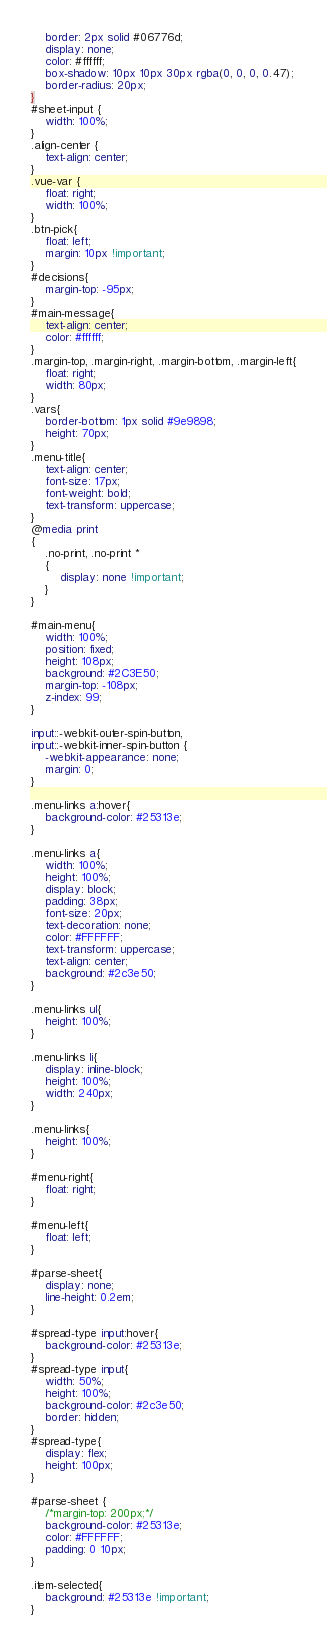<code> <loc_0><loc_0><loc_500><loc_500><_CSS_>    border: 2px solid #06776d;
    display: none;
    color: #ffffff;
    box-shadow: 10px 10px 30px rgba(0, 0, 0, 0.47);
    border-radius: 20px;
}
#sheet-input {
    width: 100%;
}
.align-center {
    text-align: center;
}
.vue-var {
    float: right;
    width: 100%;
}
.btn-pick{
    float: left;
    margin: 10px !important;
}
#decisions{
    margin-top: -95px;
}
#main-message{
    text-align: center;
    color: #ffffff;
}
.margin-top, .margin-right, .margin-bottom, .margin-left{
    float: right;
    width: 80px;
}
.vars{
    border-bottom: 1px solid #9e9898;
    height: 70px;
}
.menu-title{
    text-align: center;
    font-size: 17px;
    font-weight: bold;
    text-transform: uppercase;
}
@media print
{
    .no-print, .no-print *
    {
        display: none !important;
    }
}

#main-menu{
    width: 100%;
    position: fixed;
    height: 108px;
    background: #2C3E50;
    margin-top: -108px;
    z-index: 99;
}

input::-webkit-outer-spin-button,
input::-webkit-inner-spin-button {
    -webkit-appearance: none;
    margin: 0;
}

.menu-links a:hover{
    background-color: #25313e;
}

.menu-links a{
    width: 100%;
    height: 100%;
    display: block;
    padding: 38px;
    font-size: 20px;
    text-decoration: none;
    color: #FFFFFF;
    text-transform: uppercase;
    text-align: center;
    background: #2c3e50;
}

.menu-links ul{
    height: 100%;
}

.menu-links li{
    display: inline-block;
    height: 100%;
    width: 240px;
}

.menu-links{
    height: 100%;
}

#menu-right{
    float: right;
}

#menu-left{
    float: left;
}

#parse-sheet{
    display: none;
    line-height: 0.2em;
}

#spread-type input:hover{
    background-color: #25313e;
}
#spread-type input{
    width: 50%;
    height: 100%;
    background-color: #2c3e50;
    border: hidden;
}
#spread-type{
    display: flex;
    height: 100px;
}

#parse-sheet {
    /*margin-top: 200px;*/
    background-color: #25313e;
    color: #FFFFFF;
    padding: 0 10px;
}

.item-selected{
    background: #25313e !important;
}
</code> 